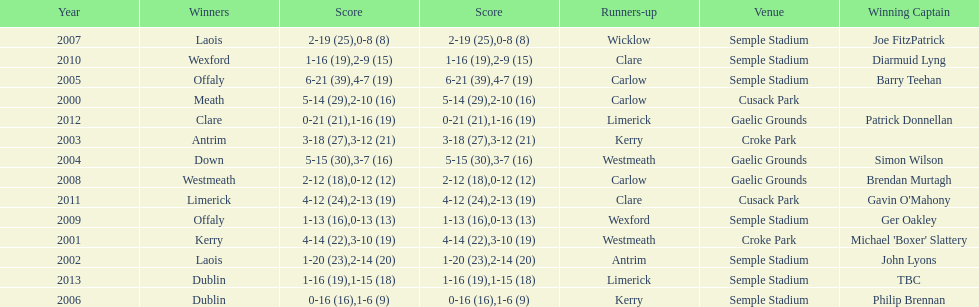Who scored the least? Wicklow. 